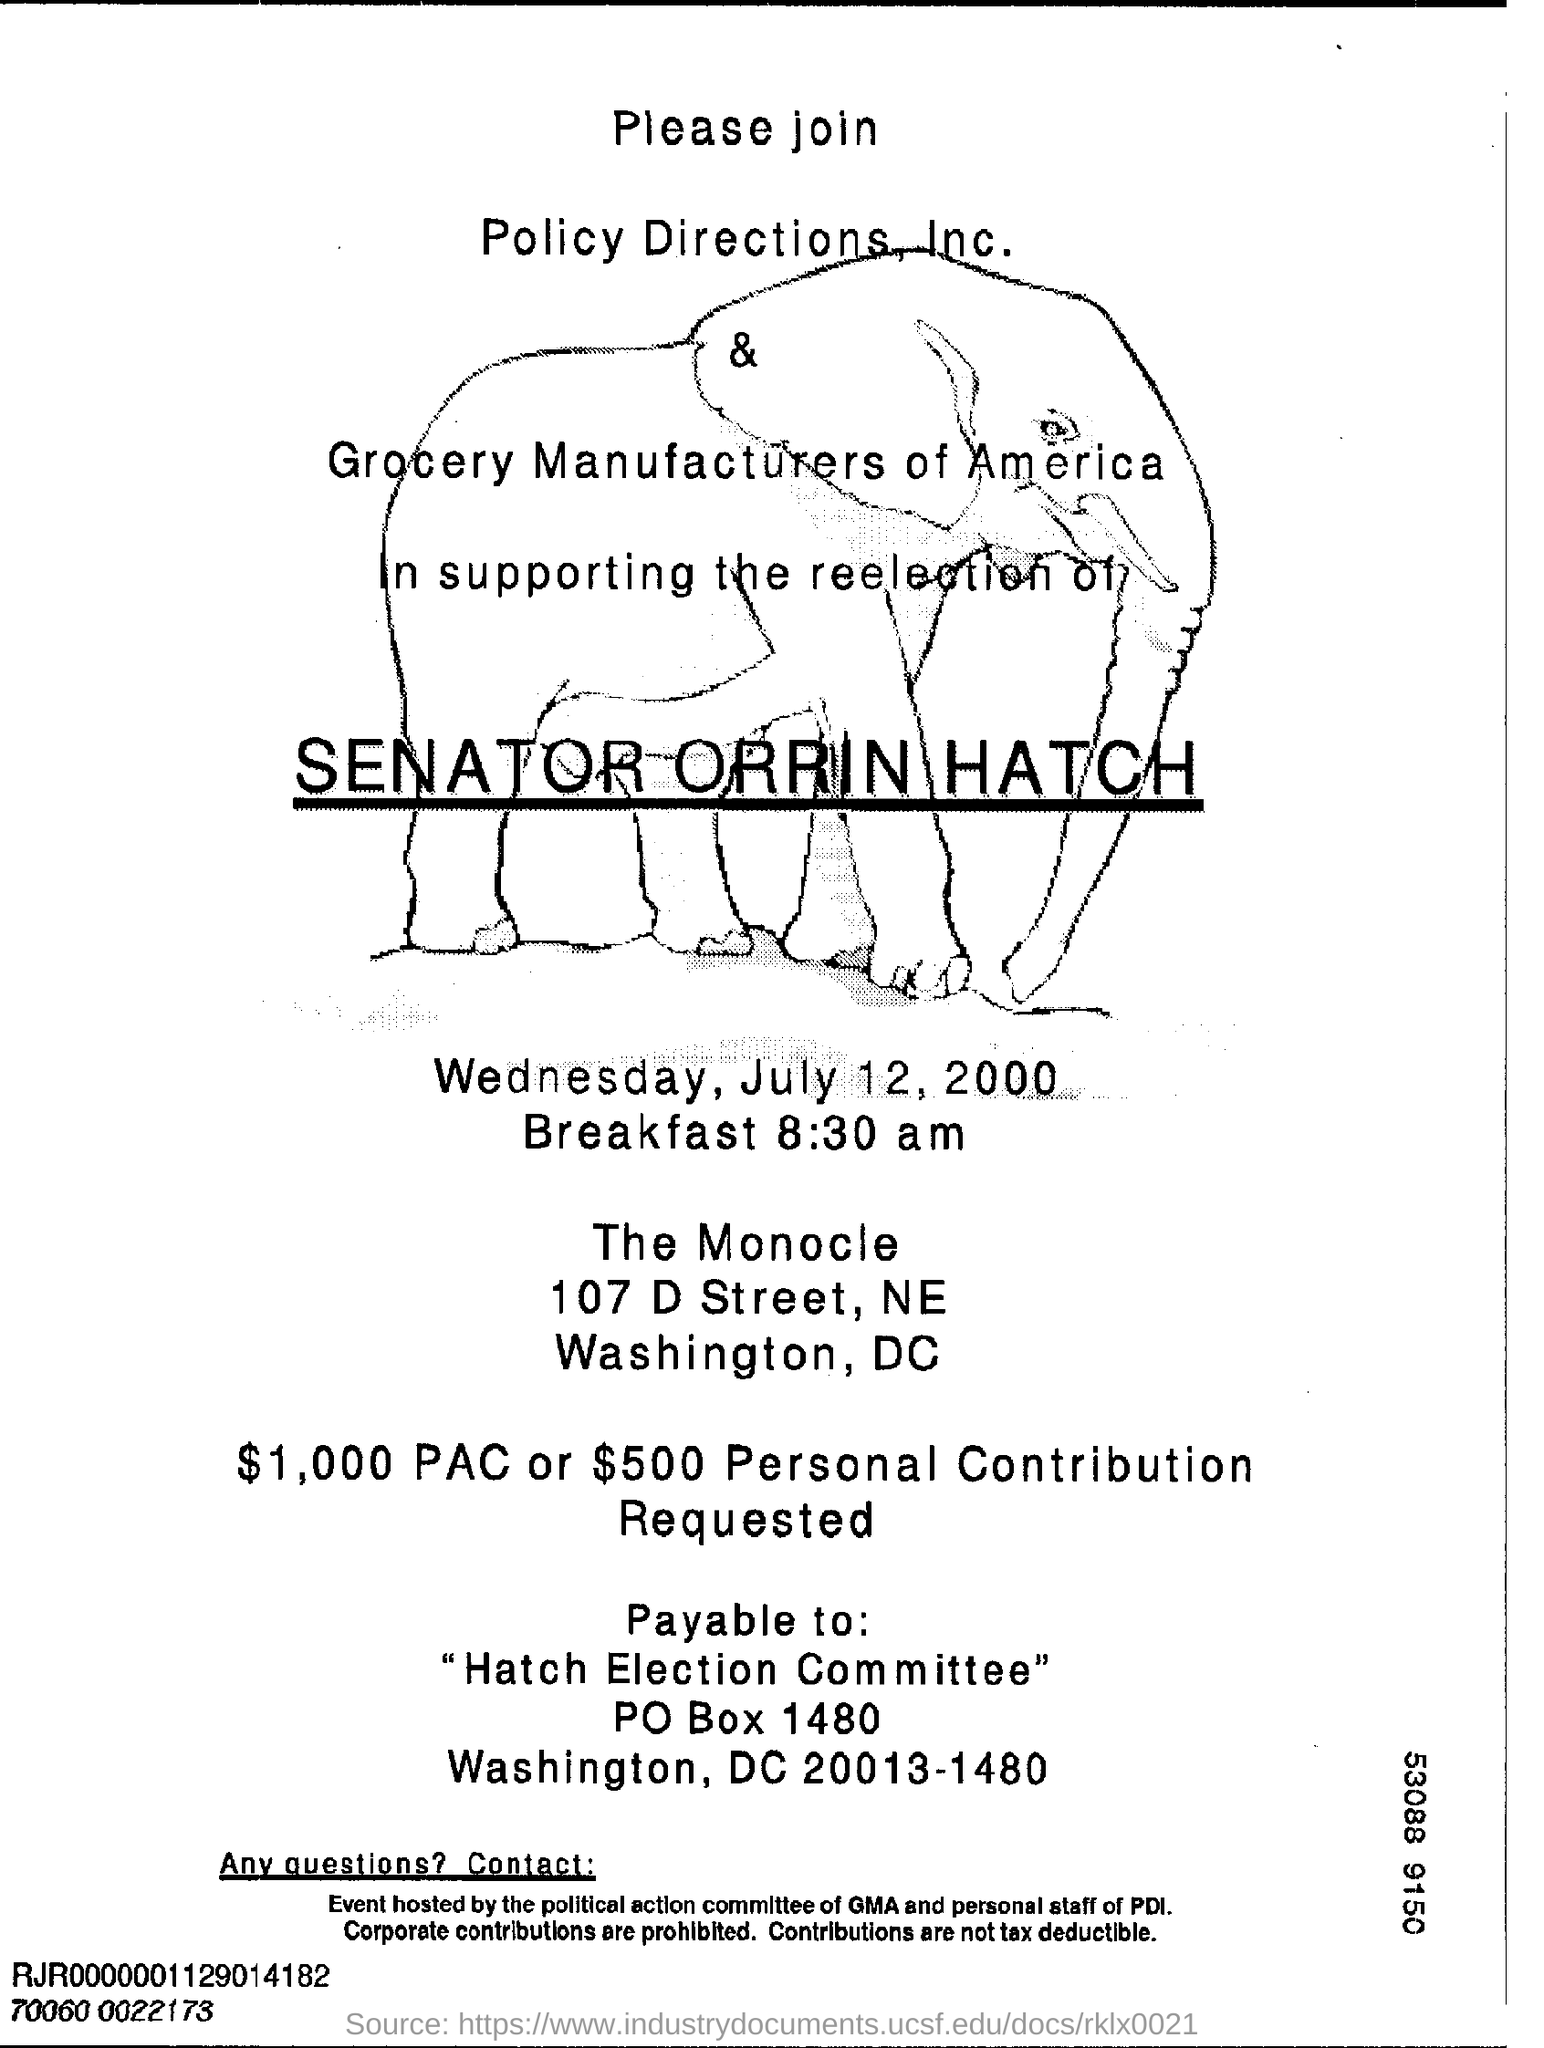Give some essential details in this illustration. Five hundred dollars is requested for personal contribution, What is the P O Box Number of the Hatch Election Committee? It is 1480. 